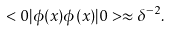<formula> <loc_0><loc_0><loc_500><loc_500>< 0 | \phi ( x ) \phi ( x ) | 0 > \approx \delta ^ { - 2 } .</formula> 